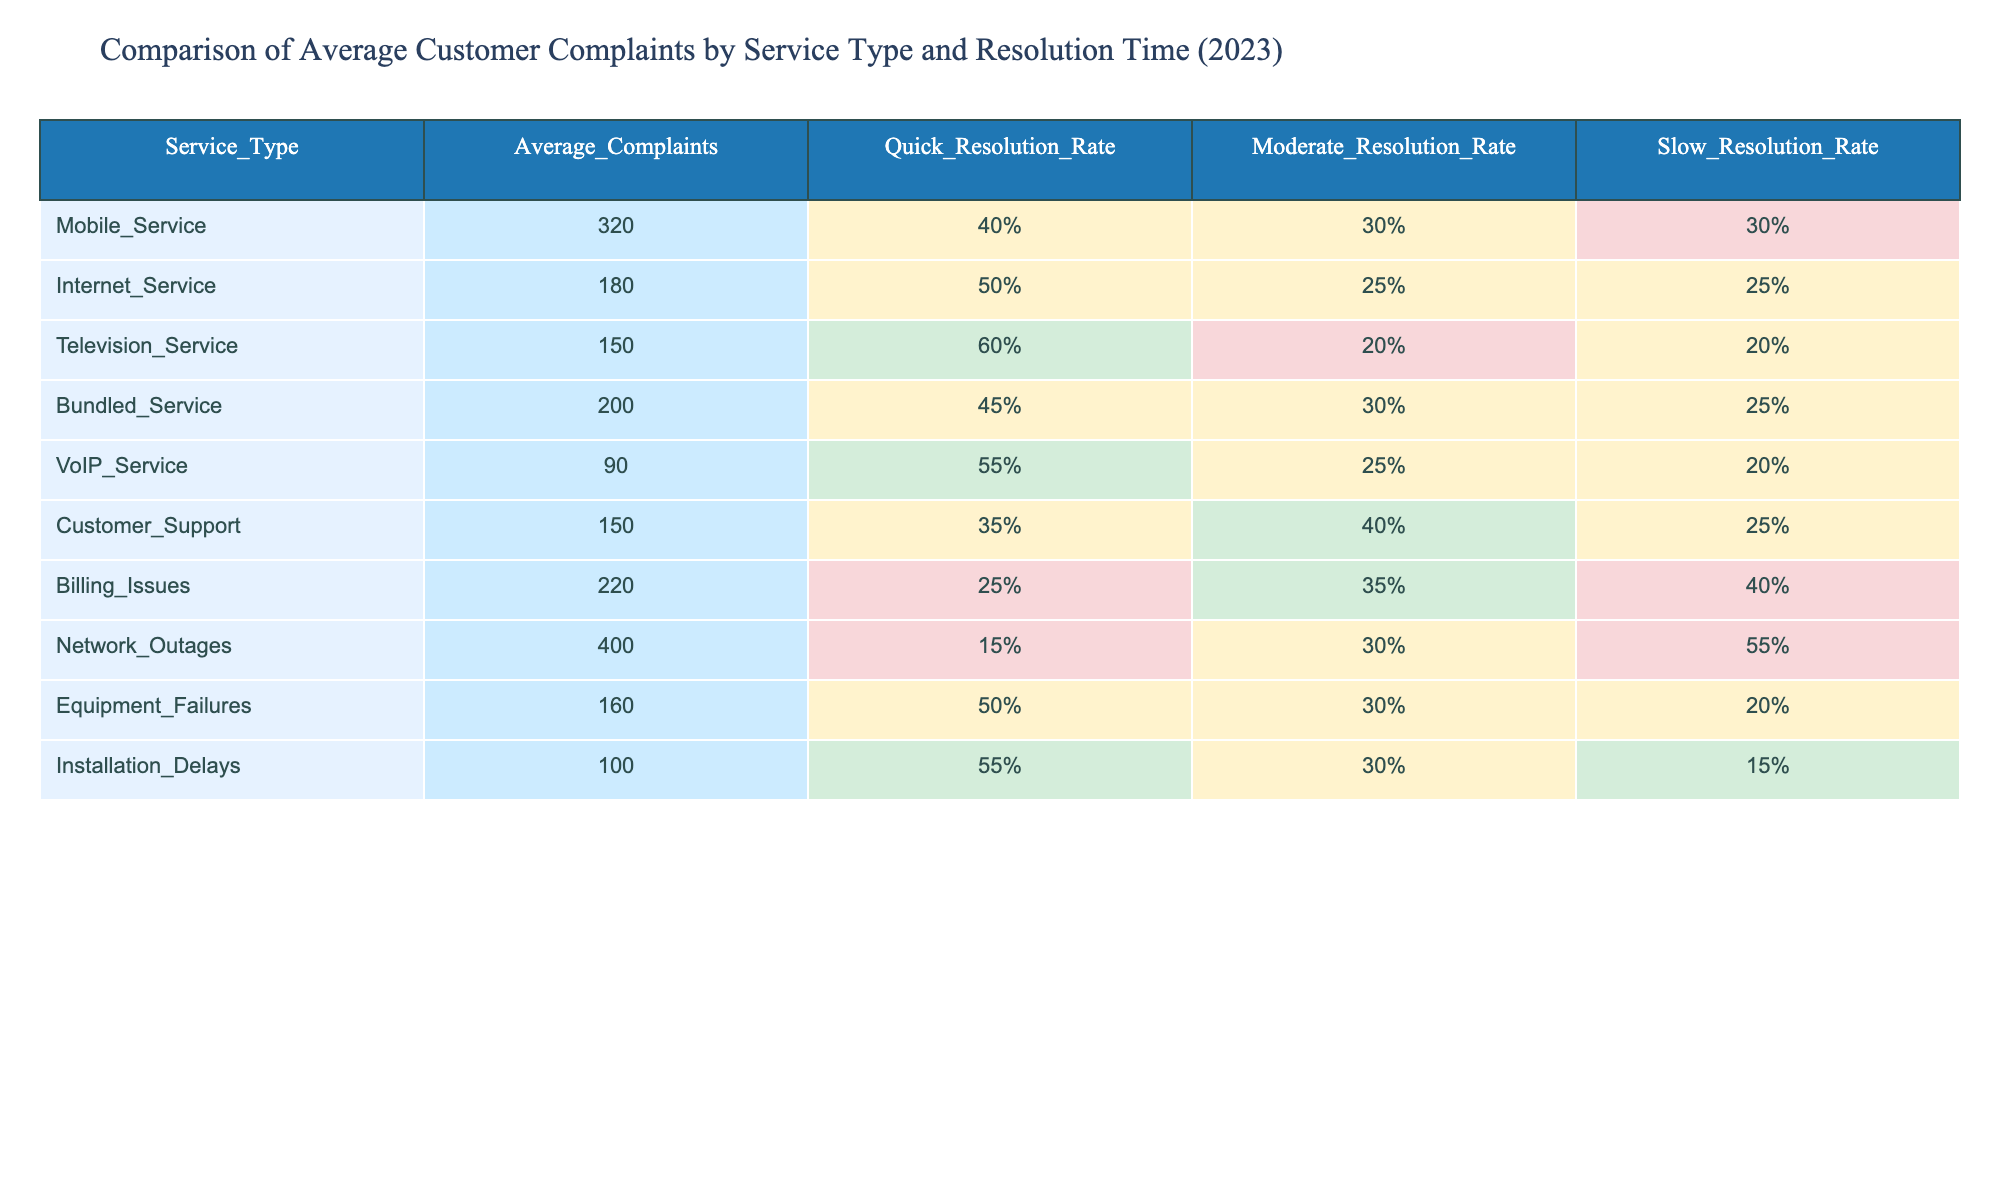What is the service type with the highest average number of complaints? The table indicates that the service type with the highest average number of complaints is Network Outages, which has 400 average complaints.
Answer: Network Outages Which service type has the highest Quick Resolution Rate? According to the table, Television Service has the highest Quick Resolution Rate at 60%.
Answer: Television Service What is the average number of complaints for internet services? The average number of complaints related to Internet Service is 180, as indicated in the table.
Answer: 180 Which service type has a higher average number of complaints: Mobile Service or Bundled Service? Mobile Service has 320 average complaints, while Bundled Service has 200 average complaints. Since 320 is greater than 200, Mobile Service has the higher number.
Answer: Mobile Service What is the difference in average complaints between Network Outages and Billing Issues? Network Outages has 400 average complaints while Billing Issues has 220. The difference is calculated as 400 - 220 = 180.
Answer: 180 Is the Slow Resolution Rate for Customer Support greater than 20%? The Slow Resolution Rate for Customer Support is listed as 25%, which is indeed greater than 20%.
Answer: Yes Which service type has the lowest Moderate Resolution Rate? By examining the table, Billing Issues has the lowest Moderate Resolution Rate at 35%.
Answer: Billing Issues If you were to categorize complaint resolution rates as satisfactory (greater than 50%), which services would be considered satisfactory? The Quick Resolution Rate for the satisfactory category would include Mobile Service (40%), Internet Service (50%), Television Service (60%), and VoIP Service (55%), as they all have rates above 50% for Quick Resolution.
Answer: Television Service, VoIP Service How many total average complaints do Mobile Service and VoIP Service have combined? The average complaints for Mobile Service is 320 and for VoIP Service is 90. The combined total is calculated as 320 + 90 = 410.
Answer: 410 Is the average complaint for Installation Delays lower than that for Equipment Failures? Installation Delays has 100 average complaints while Equipment Failures has 160 average complaints. Since 100 is less than 160, the answer is yes.
Answer: Yes 